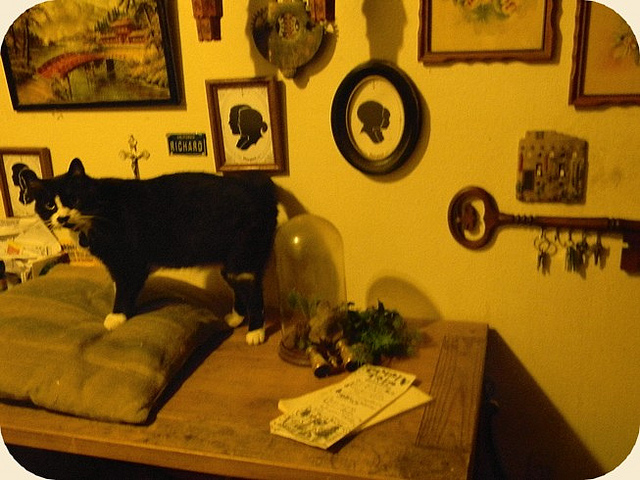Read all the text in this image. NICHARD 